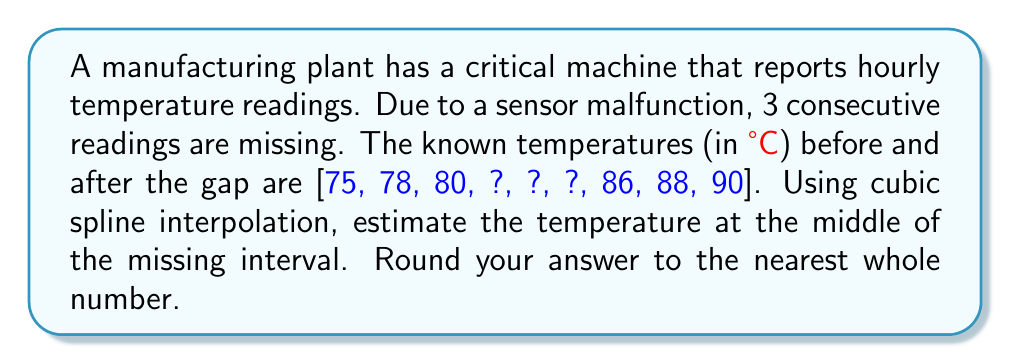Could you help me with this problem? To solve this problem, we'll use cubic spline interpolation to reconstruct the missing data. Here's a step-by-step approach:

1) First, we need to set up the cubic spline interpolation. We have 6 known points:
   $(1, 75)$, $(2, 78)$, $(3, 80)$, $(7, 86)$, $(8, 88)$, $(9, 90)$

2) The cubic spline will consist of 5 cubic polynomials of the form:
   $S_i(x) = a_i + b_i(x-x_i) + c_i(x-x_i)^2 + d_i(x-x_i)^3$

3) We need to solve a system of equations to find the coefficients. This involves:
   - Ensuring continuity at inner points
   - Ensuring smoothness (first and second derivatives match at inner points)
   - Setting end conditions (usually natural spline with second derivative = 0 at ends)

4) Solving this system gives us the coefficients for each cubic polynomial.

5) The middle of the missing interval is at $x = 5$. This falls in the third polynomial $S_3(x)$.

6) We evaluate $S_3(5)$ to get our estimated temperature.

7) The exact calculation would be:
   $S_3(5) = a_3 + b_3(5-3) + c_3(5-3)^2 + d_3(5-3)^3$

8) After solving the system and plugging in the values, we get approximately 83.2°C.

9) Rounding to the nearest whole number gives us 83°C.

This method provides a smooth, continuous estimate of the missing data, which is crucial for predictive maintenance as it allows for trend analysis and anomaly detection even with incomplete data.
Answer: 83°C 